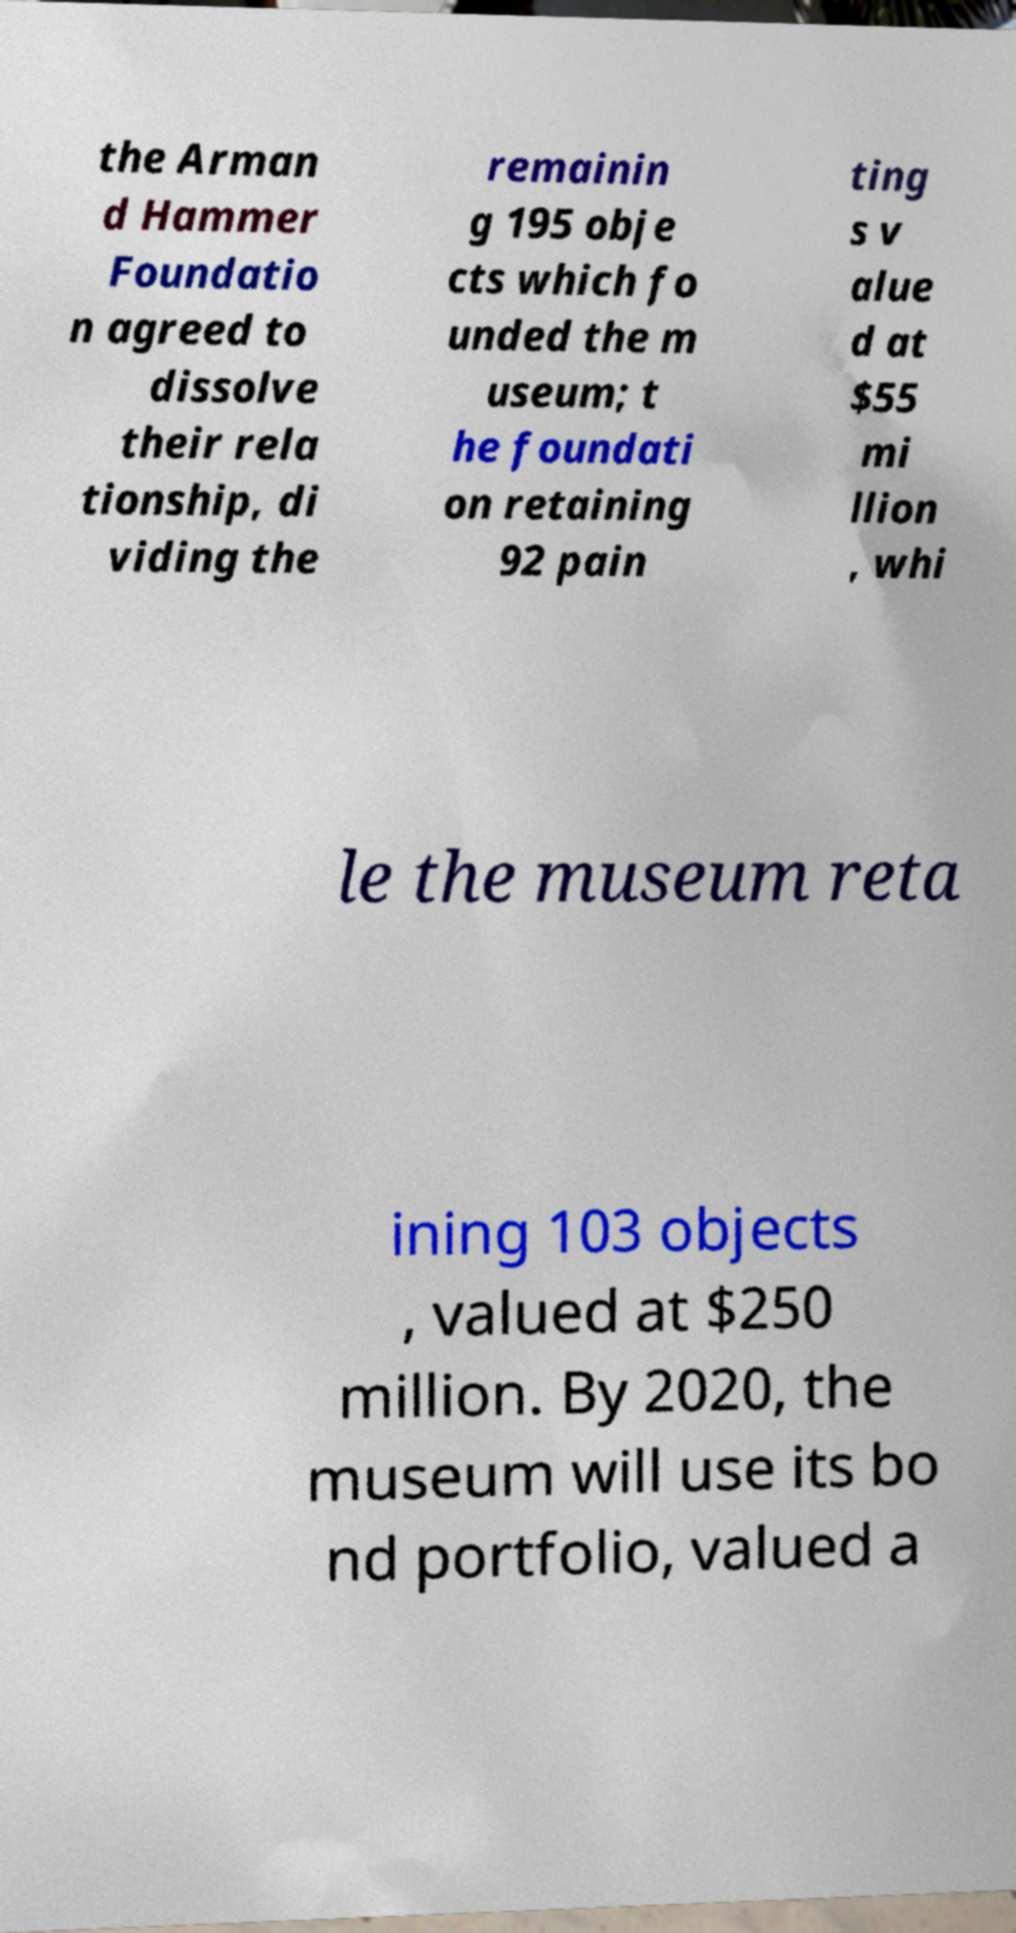Could you extract and type out the text from this image? the Arman d Hammer Foundatio n agreed to dissolve their rela tionship, di viding the remainin g 195 obje cts which fo unded the m useum; t he foundati on retaining 92 pain ting s v alue d at $55 mi llion , whi le the museum reta ining 103 objects , valued at $250 million. By 2020, the museum will use its bo nd portfolio, valued a 